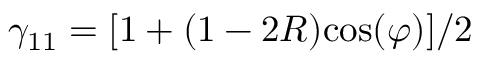Convert formula to latex. <formula><loc_0><loc_0><loc_500><loc_500>\gamma _ { 1 1 } = [ 1 + ( 1 - 2 R ) \cos ( \varphi ) ] / 2</formula> 